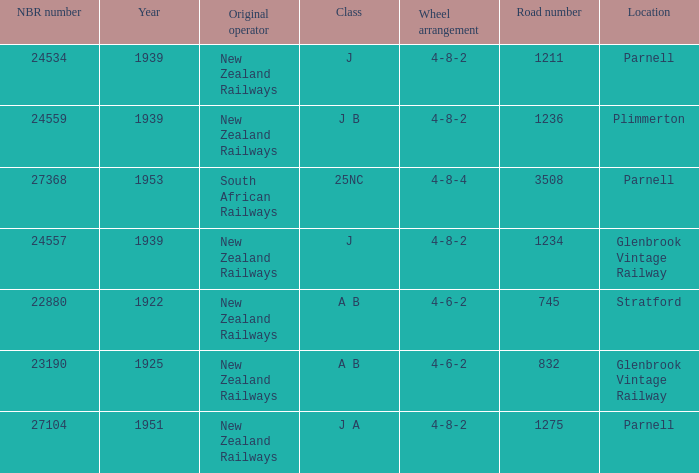Which class starts after 1939 and has a road number smaller than 3508? J A. 